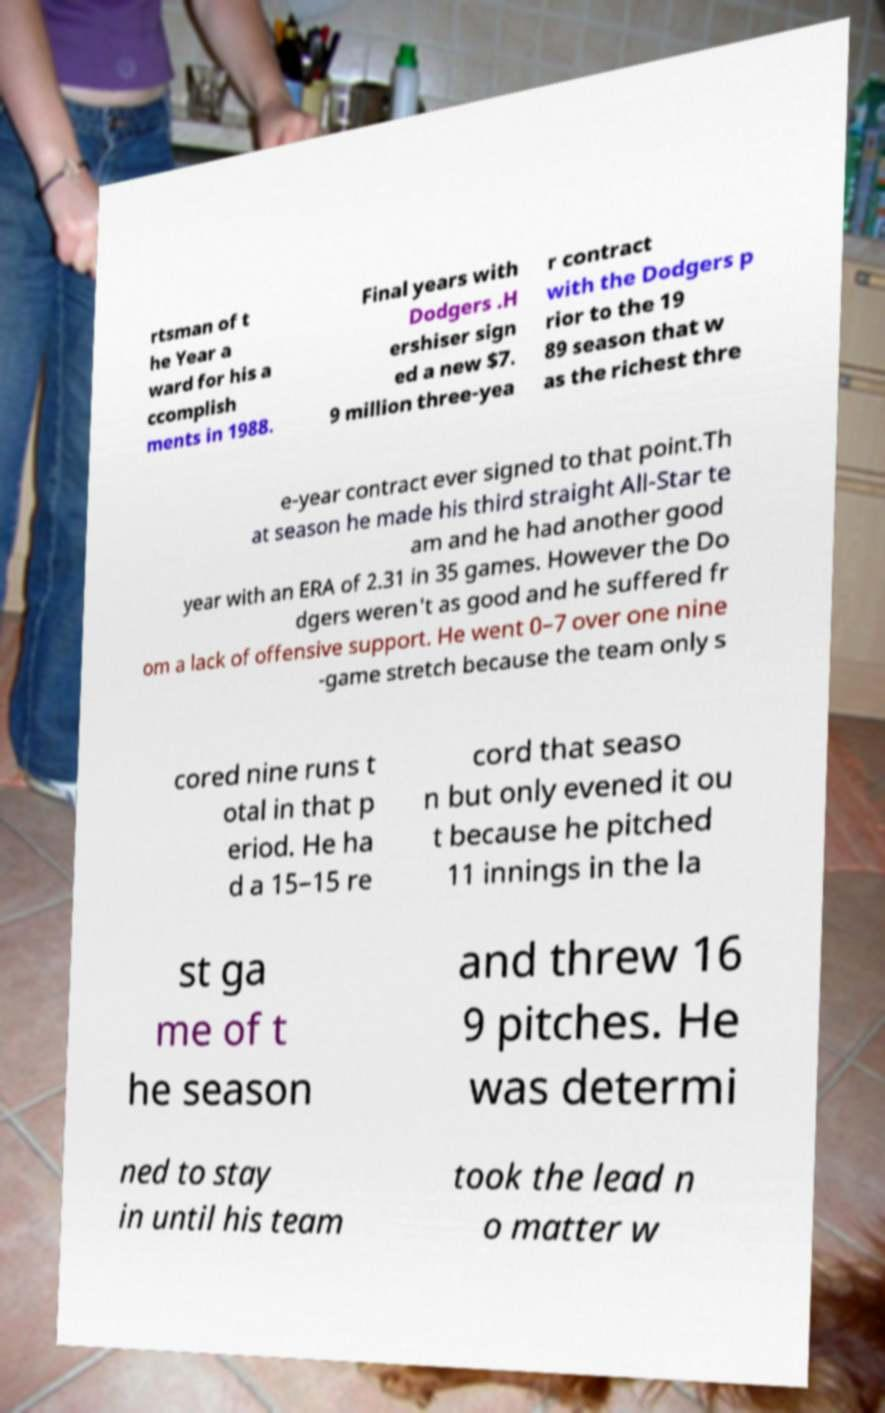Please identify and transcribe the text found in this image. rtsman of t he Year a ward for his a ccomplish ments in 1988. Final years with Dodgers .H ershiser sign ed a new $7. 9 million three-yea r contract with the Dodgers p rior to the 19 89 season that w as the richest thre e-year contract ever signed to that point.Th at season he made his third straight All-Star te am and he had another good year with an ERA of 2.31 in 35 games. However the Do dgers weren't as good and he suffered fr om a lack of offensive support. He went 0–7 over one nine -game stretch because the team only s cored nine runs t otal in that p eriod. He ha d a 15–15 re cord that seaso n but only evened it ou t because he pitched 11 innings in the la st ga me of t he season and threw 16 9 pitches. He was determi ned to stay in until his team took the lead n o matter w 